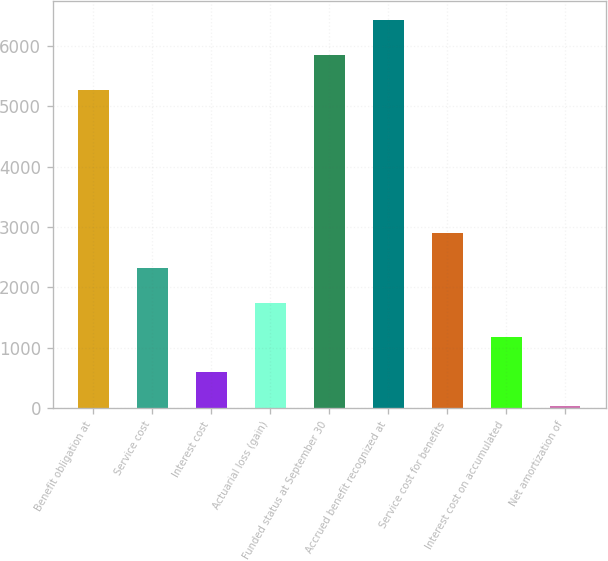Convert chart to OTSL. <chart><loc_0><loc_0><loc_500><loc_500><bar_chart><fcel>Benefit obligation at<fcel>Service cost<fcel>Interest cost<fcel>Actuarial loss (gain)<fcel>Funded status at September 30<fcel>Accrued benefit recognized at<fcel>Service cost for benefits<fcel>Interest cost on accumulated<fcel>Net amortization of<nl><fcel>5276<fcel>2319.4<fcel>601.6<fcel>1746.8<fcel>5848.6<fcel>6421.2<fcel>2892<fcel>1174.2<fcel>29<nl></chart> 